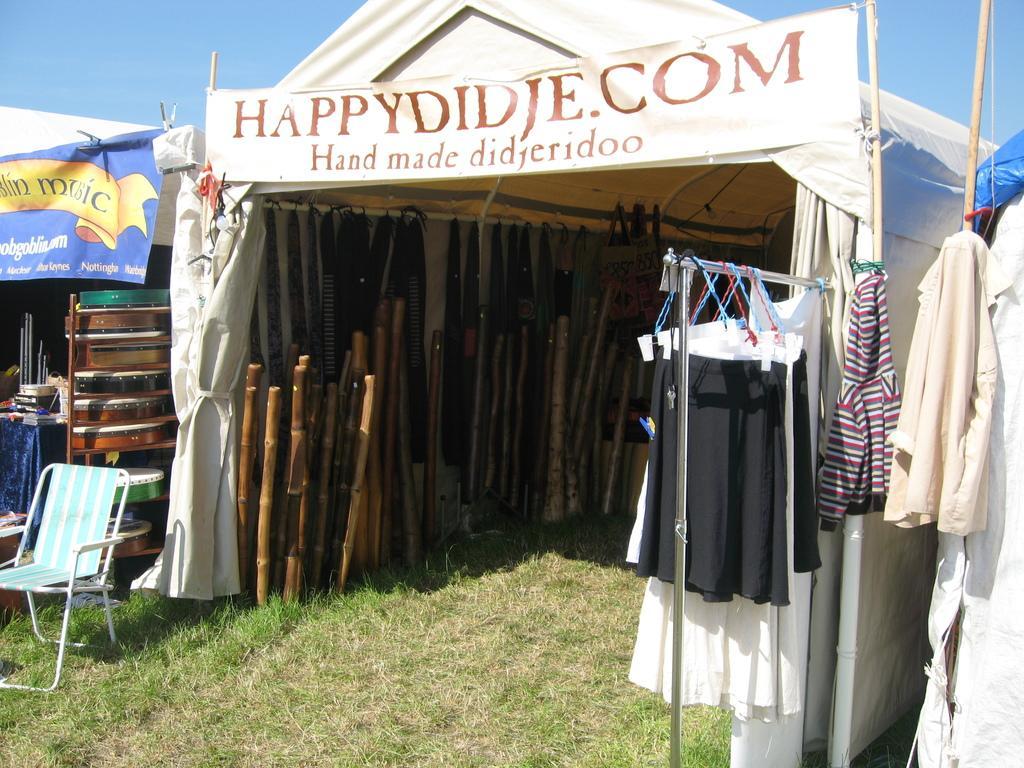Can you describe this image briefly? At the bottom of the picture, we see grass. On the right side, we see a hanger to which clothes are hanged. We see wooden sticks and belts are hanged under the white tent. We see a white banner with some text written on it. Beside that, we see a chair and wooden objects are placed under the white tent. On the left side, we see a blue banner with some text written on it. At the top of the picture, we see the sky. 